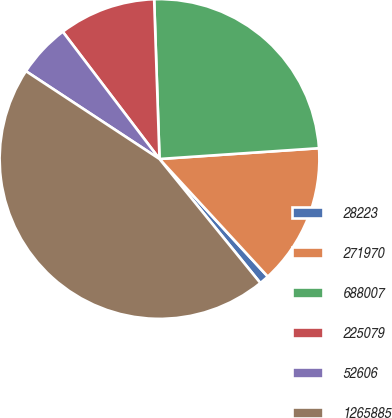<chart> <loc_0><loc_0><loc_500><loc_500><pie_chart><fcel>28223<fcel>271970<fcel>688007<fcel>225079<fcel>52606<fcel>1265885<nl><fcel>0.98%<fcel>14.23%<fcel>24.46%<fcel>9.81%<fcel>5.4%<fcel>45.13%<nl></chart> 